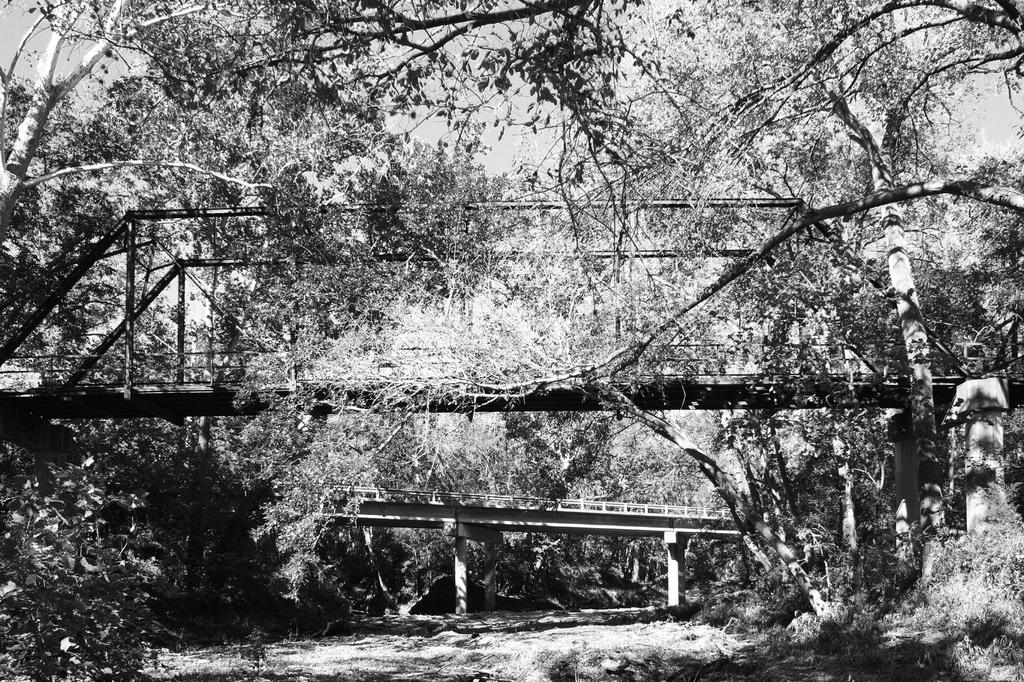What is the color scheme of the image? The image is black and white. What structures can be seen in the image? There are bridges in the image. What type of vegetation is present in the image? There are trees in the image. What is at the bottom of the image? There is grass at the bottom of the image. How much hope is stored on the shelf in the image? There is no shelf or mention of hope in the image; it features bridges, trees, and grass in a black and white color scheme. 